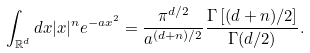<formula> <loc_0><loc_0><loc_500><loc_500>\int _ { \mathbb { R } ^ { d } } d x | x | ^ { n } e ^ { - a x ^ { 2 } } = \frac { \pi ^ { d / 2 } } { a ^ { ( d + n ) / 2 } } \frac { \Gamma \left [ ( d + n ) / 2 \right ] } { \Gamma ( d / 2 ) } .</formula> 